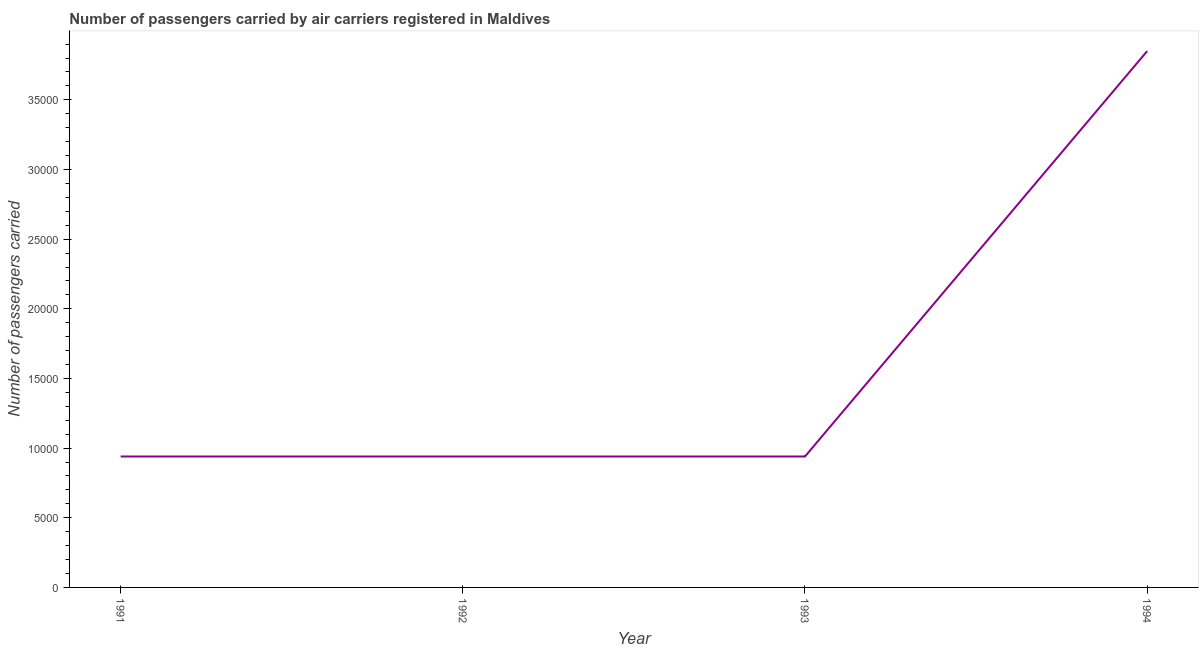What is the number of passengers carried in 1993?
Keep it short and to the point. 9400. Across all years, what is the maximum number of passengers carried?
Provide a short and direct response. 3.85e+04. Across all years, what is the minimum number of passengers carried?
Make the answer very short. 9400. In which year was the number of passengers carried minimum?
Give a very brief answer. 1991. What is the sum of the number of passengers carried?
Provide a short and direct response. 6.67e+04. What is the difference between the number of passengers carried in 1991 and 1992?
Offer a very short reply. 0. What is the average number of passengers carried per year?
Provide a short and direct response. 1.67e+04. What is the median number of passengers carried?
Your answer should be compact. 9400. Do a majority of the years between 1994 and 1991 (inclusive) have number of passengers carried greater than 7000 ?
Offer a very short reply. Yes. Is the difference between the number of passengers carried in 1992 and 1993 greater than the difference between any two years?
Your response must be concise. No. What is the difference between the highest and the second highest number of passengers carried?
Offer a very short reply. 2.91e+04. What is the difference between the highest and the lowest number of passengers carried?
Keep it short and to the point. 2.91e+04. How many years are there in the graph?
Offer a terse response. 4. What is the difference between two consecutive major ticks on the Y-axis?
Offer a terse response. 5000. Are the values on the major ticks of Y-axis written in scientific E-notation?
Provide a succinct answer. No. What is the title of the graph?
Provide a short and direct response. Number of passengers carried by air carriers registered in Maldives. What is the label or title of the X-axis?
Keep it short and to the point. Year. What is the label or title of the Y-axis?
Keep it short and to the point. Number of passengers carried. What is the Number of passengers carried of 1991?
Ensure brevity in your answer.  9400. What is the Number of passengers carried in 1992?
Make the answer very short. 9400. What is the Number of passengers carried in 1993?
Offer a terse response. 9400. What is the Number of passengers carried in 1994?
Your answer should be very brief. 3.85e+04. What is the difference between the Number of passengers carried in 1991 and 1992?
Your response must be concise. 0. What is the difference between the Number of passengers carried in 1991 and 1994?
Your answer should be very brief. -2.91e+04. What is the difference between the Number of passengers carried in 1992 and 1993?
Provide a short and direct response. 0. What is the difference between the Number of passengers carried in 1992 and 1994?
Offer a terse response. -2.91e+04. What is the difference between the Number of passengers carried in 1993 and 1994?
Provide a succinct answer. -2.91e+04. What is the ratio of the Number of passengers carried in 1991 to that in 1993?
Make the answer very short. 1. What is the ratio of the Number of passengers carried in 1991 to that in 1994?
Your answer should be very brief. 0.24. What is the ratio of the Number of passengers carried in 1992 to that in 1993?
Make the answer very short. 1. What is the ratio of the Number of passengers carried in 1992 to that in 1994?
Make the answer very short. 0.24. What is the ratio of the Number of passengers carried in 1993 to that in 1994?
Your answer should be compact. 0.24. 